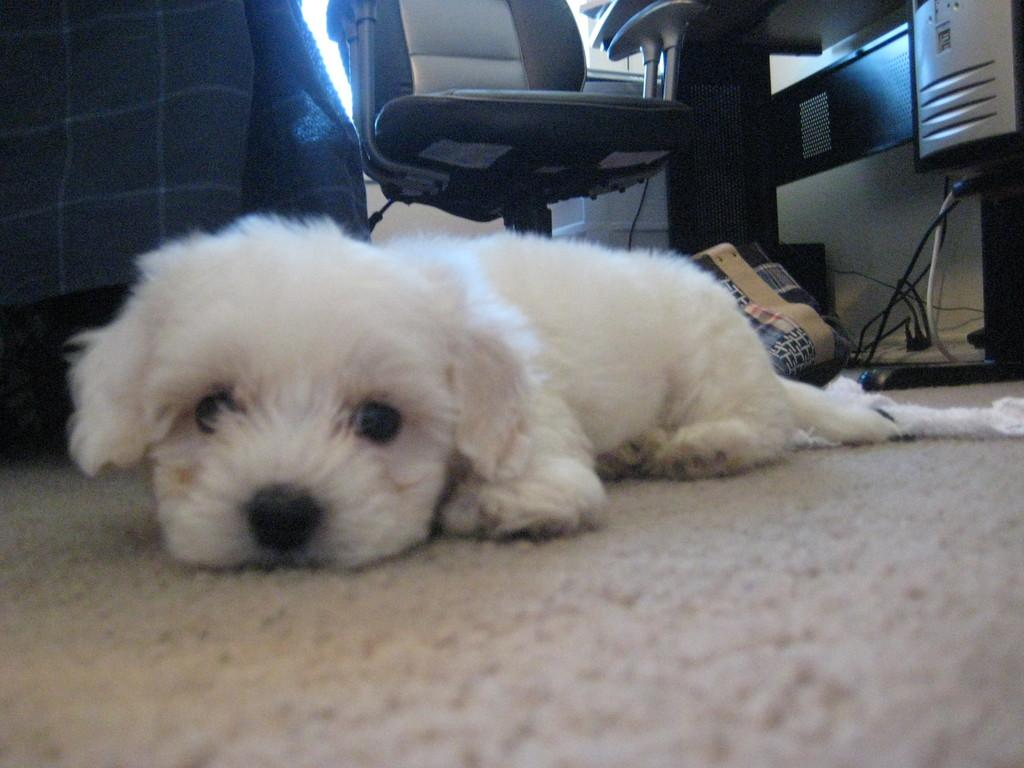What is the main subject of the image? There is a dog lying on the carpet in the image. What else can be seen in the image besides the dog? There is a bag, a chair, a table, and cables visible in the image. What list is the dog checking off in the image? There is no list present in the image; the dog is simply lying on the carpet. 